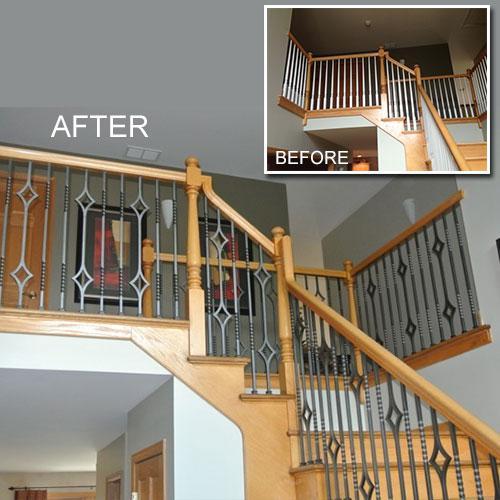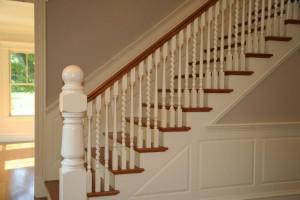The first image is the image on the left, the second image is the image on the right. Analyze the images presented: Is the assertion "The left image shows a staircase banister with dark wrought iron bars, and the right image shows a staircase with white spindles on its banister." valid? Answer yes or no. Yes. The first image is the image on the left, the second image is the image on the right. Considering the images on both sides, is "There are four twisted white pole ment to build a staircase." valid? Answer yes or no. No. 